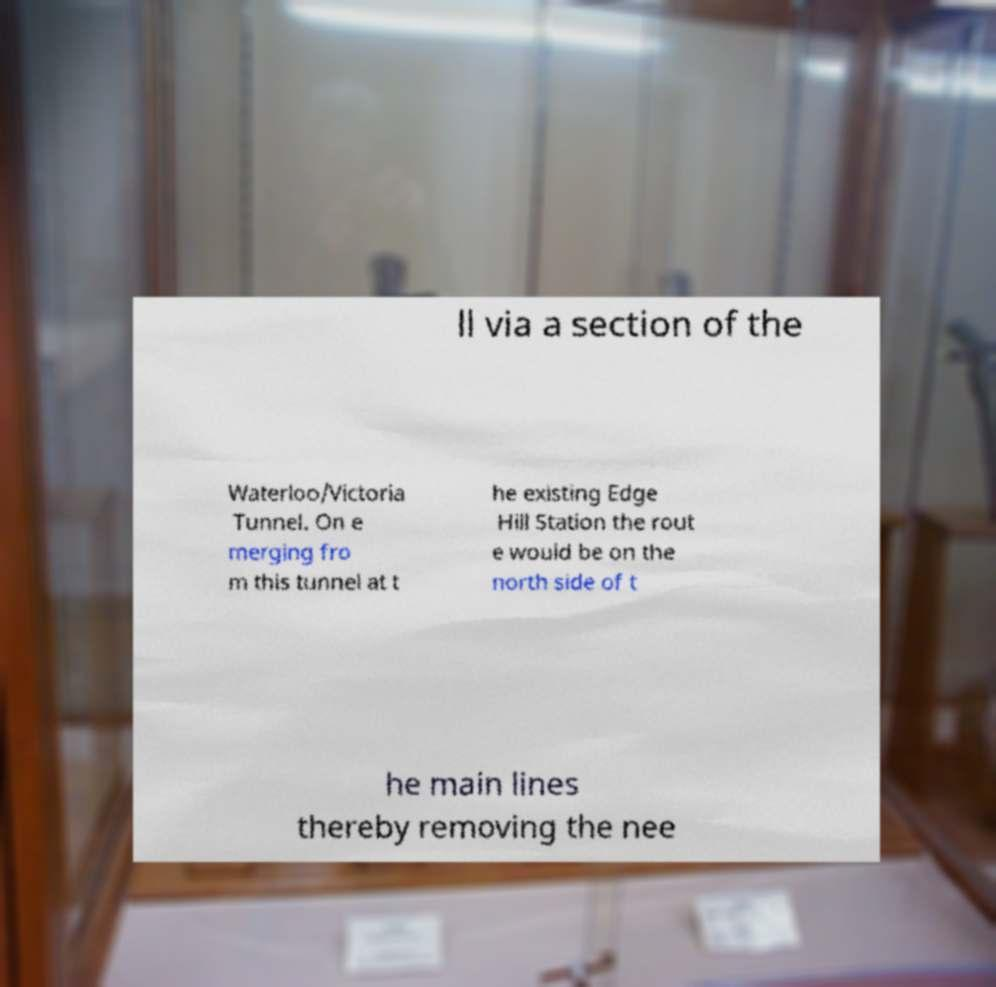Could you assist in decoding the text presented in this image and type it out clearly? ll via a section of the Waterloo/Victoria Tunnel. On e merging fro m this tunnel at t he existing Edge Hill Station the rout e would be on the north side of t he main lines thereby removing the nee 